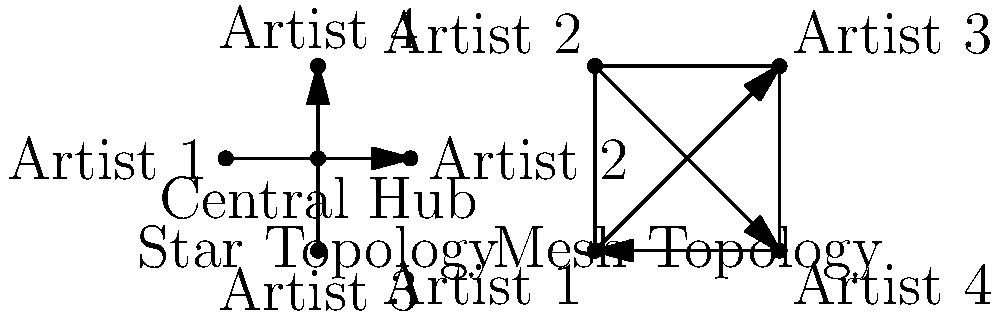As a trap artist collaborating with others, which network topology would be more efficient for a music collaboration platform: star or mesh? Consider factors like direct communication, centralized control, and scalability for adding new artists to the network. To determine the most efficient network topology for a music collaboration platform, let's analyze both star and mesh configurations:

1. Star Topology:
   - Central hub connects all artists
   - All communication goes through the central node
   - Pros:
     a) Centralized control and management
     b) Easy to add new artists (just connect to the hub)
   - Cons:
     a) Single point of failure (if hub fails, entire network fails)
     b) Potential bottleneck at the central hub

2. Mesh Topology:
   - All artists are directly connected to each other
   - No central hub
   - Pros:
     a) Direct communication between artists
     b) No single point of failure
     c) Better for real-time collaboration
   - Cons:
     a) More complex to manage
     b) Harder to scale (need to connect new artist to all existing ones)

3. Considerations for trap music collaboration:
   - Real-time collaboration is crucial for creating beats and flows
   - Direct communication between artists is important for freestyle sessions
   - Scalability is essential for featuring multiple artists on tracks

4. Conclusion:
   For trap music collaboration, the mesh topology is more efficient because:
   - It allows direct, real-time communication between artists
   - There's no central bottleneck, which is crucial for fast-paced trap production
   - It's more resilient, as the failure of one node doesn't affect the entire network
   - While scaling is more complex, it's manageable for the typical number of artists collaborating on a track

Despite the slightly higher complexity, the benefits of direct communication and resilience make mesh topology more suitable for trap music collaboration platforms.
Answer: Mesh topology 